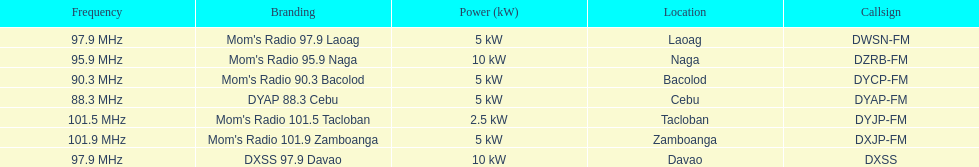How many times is the frequency greater than 95? 5. 